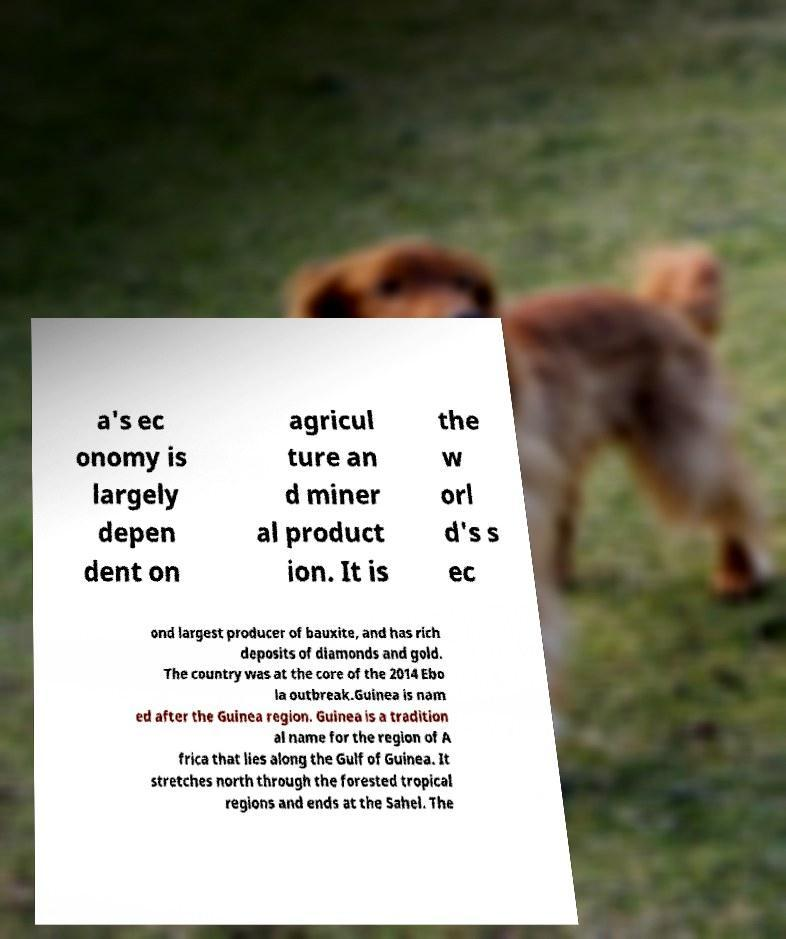Can you read and provide the text displayed in the image?This photo seems to have some interesting text. Can you extract and type it out for me? a's ec onomy is largely depen dent on agricul ture an d miner al product ion. It is the w orl d's s ec ond largest producer of bauxite, and has rich deposits of diamonds and gold. The country was at the core of the 2014 Ebo la outbreak.Guinea is nam ed after the Guinea region. Guinea is a tradition al name for the region of A frica that lies along the Gulf of Guinea. It stretches north through the forested tropical regions and ends at the Sahel. The 